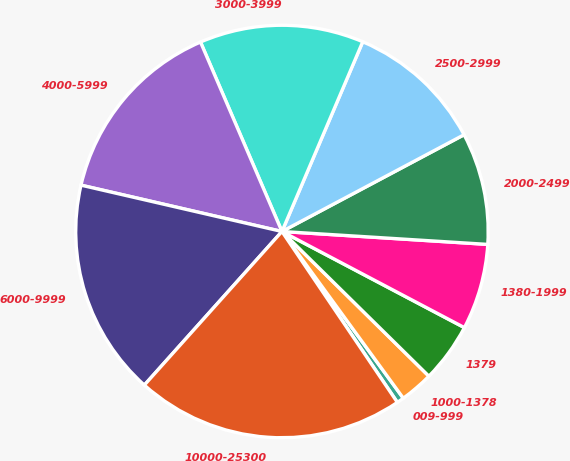Convert chart to OTSL. <chart><loc_0><loc_0><loc_500><loc_500><pie_chart><fcel>009-999<fcel>1000-1378<fcel>1379<fcel>1380-1999<fcel>2000-2499<fcel>2500-2999<fcel>3000-3999<fcel>4000-5999<fcel>6000-9999<fcel>10000-25300<nl><fcel>0.56%<fcel>2.61%<fcel>4.66%<fcel>6.72%<fcel>8.77%<fcel>10.82%<fcel>12.87%<fcel>14.93%<fcel>16.98%<fcel>21.08%<nl></chart> 